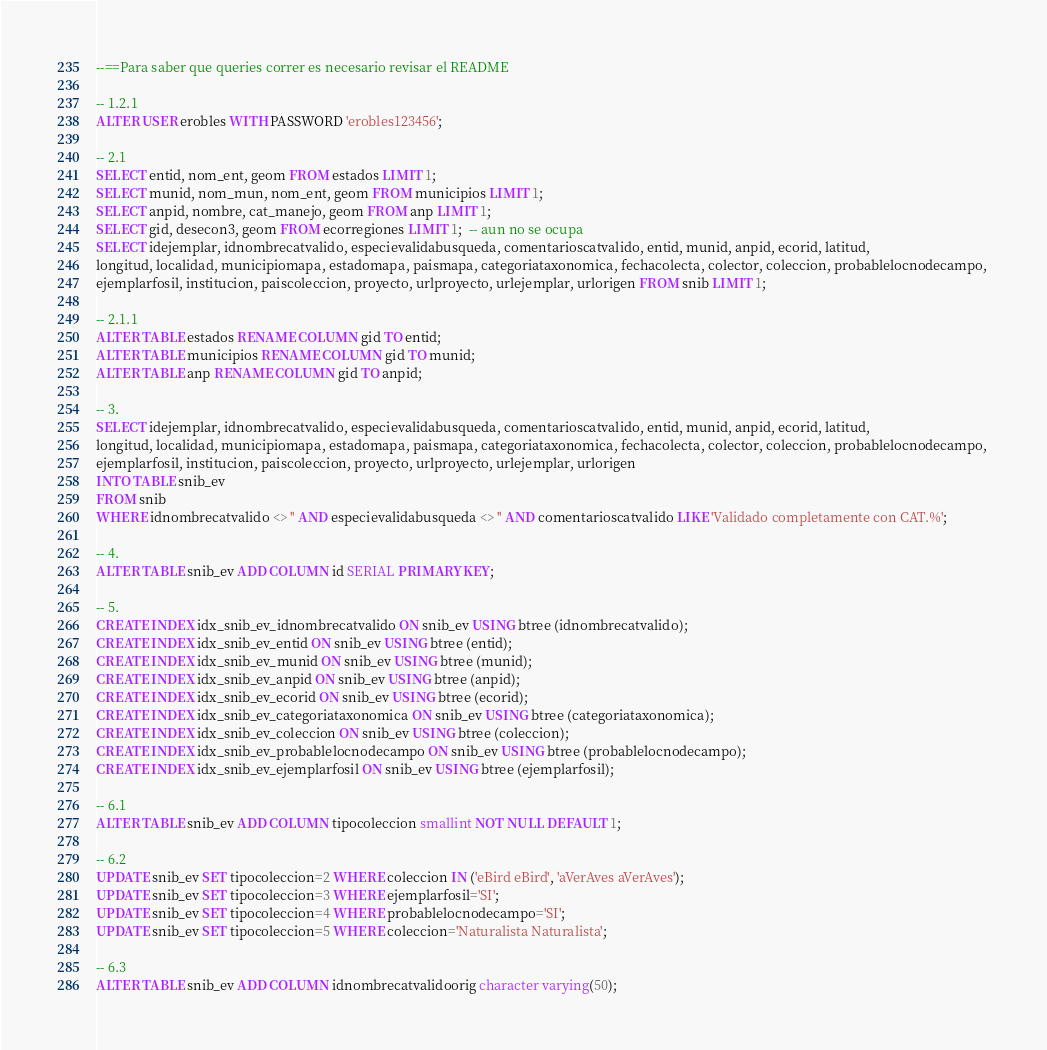Convert code to text. <code><loc_0><loc_0><loc_500><loc_500><_SQL_>--==Para saber que queries correr es necesario revisar el README

-- 1.2.1
ALTER USER erobles WITH PASSWORD 'erobles123456';

-- 2.1
SELECT entid, nom_ent, geom FROM estados LIMIT 1;
SELECT munid, nom_mun, nom_ent, geom FROM municipios LIMIT 1;
SELECT anpid, nombre, cat_manejo, geom FROM anp LIMIT 1;
SELECT gid, desecon3, geom FROM ecorregiones LIMIT 1;  -- aun no se ocupa
SELECT idejemplar, idnombrecatvalido, especievalidabusqueda, comentarioscatvalido, entid, munid, anpid, ecorid, latitud, 
longitud, localidad, municipiomapa, estadomapa, paismapa, categoriataxonomica, fechacolecta, colector, coleccion, probablelocnodecampo, 
ejemplarfosil, institucion, paiscoleccion, proyecto, urlproyecto, urlejemplar, urlorigen FROM snib LIMIT 1;

-- 2.1.1
ALTER TABLE estados RENAME COLUMN gid TO entid;
ALTER TABLE municipios RENAME COLUMN gid TO munid;
ALTER TABLE anp RENAME COLUMN gid TO anpid;

-- 3.
SELECT idejemplar, idnombrecatvalido, especievalidabusqueda, comentarioscatvalido, entid, munid, anpid, ecorid, latitud, 
longitud, localidad, municipiomapa, estadomapa, paismapa, categoriataxonomica, fechacolecta, colector, coleccion, probablelocnodecampo, 
ejemplarfosil, institucion, paiscoleccion, proyecto, urlproyecto, urlejemplar, urlorigen
INTO TABLE snib_ev 
FROM snib 
WHERE idnombrecatvalido <> '' AND especievalidabusqueda <> '' AND comentarioscatvalido LIKE 'Validado completamente con CAT.%';

-- 4.
ALTER TABLE snib_ev ADD COLUMN id SERIAL PRIMARY KEY;

-- 5.
CREATE INDEX idx_snib_ev_idnombrecatvalido ON snib_ev USING btree (idnombrecatvalido);
CREATE INDEX idx_snib_ev_entid ON snib_ev USING btree (entid);
CREATE INDEX idx_snib_ev_munid ON snib_ev USING btree (munid);
CREATE INDEX idx_snib_ev_anpid ON snib_ev USING btree (anpid);
CREATE INDEX idx_snib_ev_ecorid ON snib_ev USING btree (ecorid);
CREATE INDEX idx_snib_ev_categoriataxonomica ON snib_ev USING btree (categoriataxonomica);
CREATE INDEX idx_snib_ev_coleccion ON snib_ev USING btree (coleccion);
CREATE INDEX idx_snib_ev_probablelocnodecampo ON snib_ev USING btree (probablelocnodecampo);
CREATE INDEX idx_snib_ev_ejemplarfosil ON snib_ev USING btree (ejemplarfosil);

-- 6.1
ALTER TABLE snib_ev ADD COLUMN tipocoleccion smallint NOT NULL DEFAULT 1;

-- 6.2
UPDATE snib_ev SET tipocoleccion=2 WHERE coleccion IN ('eBird eBird', 'aVerAves aVerAves');
UPDATE snib_ev SET tipocoleccion=3 WHERE ejemplarfosil='SI';
UPDATE snib_ev SET tipocoleccion=4 WHERE probablelocnodecampo='SI';
UPDATE snib_ev SET tipocoleccion=5 WHERE coleccion='Naturalista Naturalista';

-- 6.3
ALTER TABLE snib_ev ADD COLUMN idnombrecatvalidoorig character varying(50);
</code> 